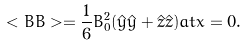Convert formula to latex. <formula><loc_0><loc_0><loc_500><loc_500>< { B } { B } > = \frac { 1 } { 6 } B _ { 0 } ^ { 2 } ( \hat { y } \hat { y } + \hat { z } \hat { z } ) a t x = 0 .</formula> 